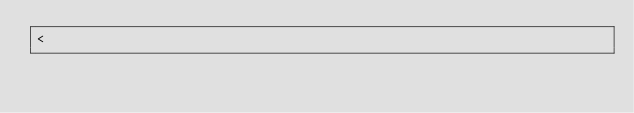Convert code to text. <code><loc_0><loc_0><loc_500><loc_500><_D_><</code> 